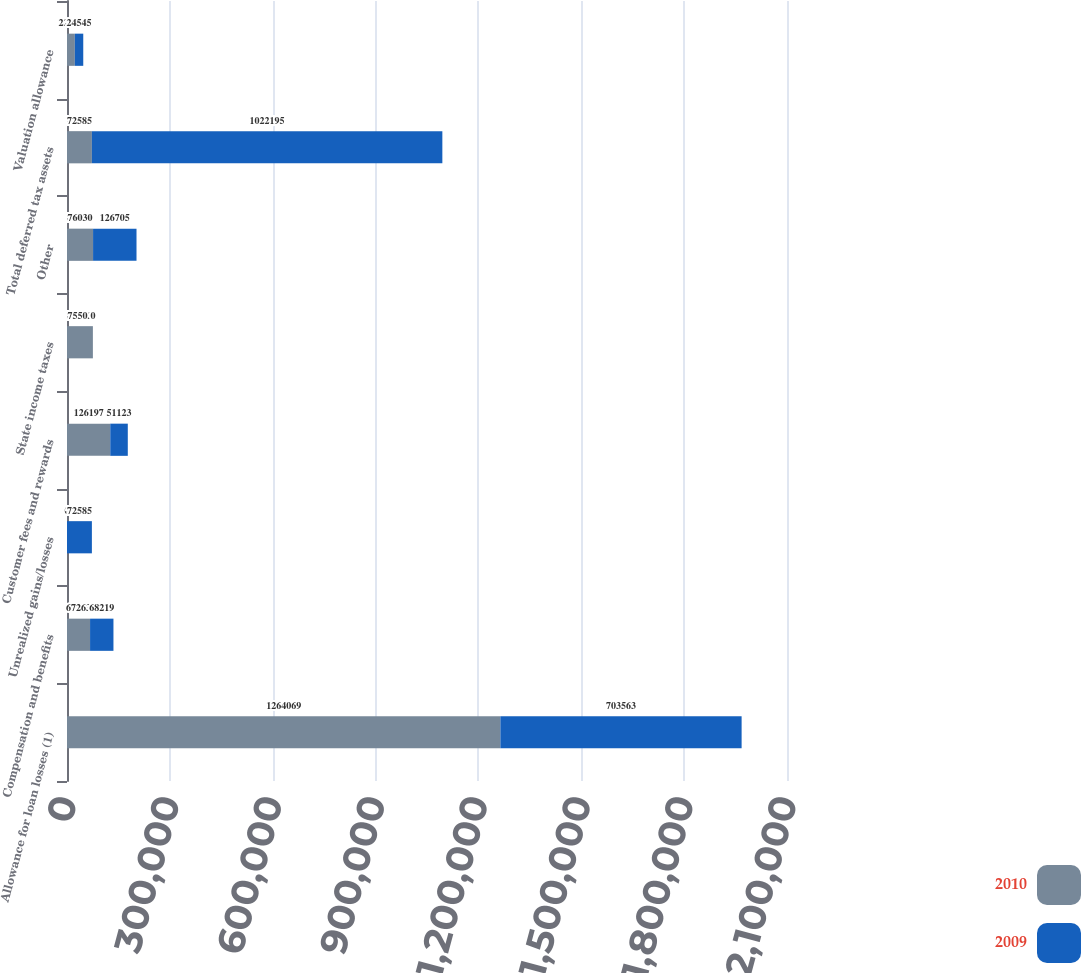Convert chart to OTSL. <chart><loc_0><loc_0><loc_500><loc_500><stacked_bar_chart><ecel><fcel>Allowance for loan losses (1)<fcel>Compensation and benefits<fcel>Unrealized gains/losses<fcel>Customer fees and rewards<fcel>State income taxes<fcel>Other<fcel>Total deferred tax assets<fcel>Valuation allowance<nl><fcel>2010<fcel>1.26407e+06<fcel>67263<fcel>0<fcel>126197<fcel>75503<fcel>76030<fcel>72585<fcel>22876<nl><fcel>2009<fcel>703563<fcel>68219<fcel>72585<fcel>51123<fcel>0<fcel>126705<fcel>1.0222e+06<fcel>24545<nl></chart> 